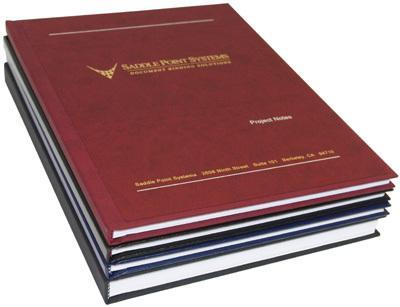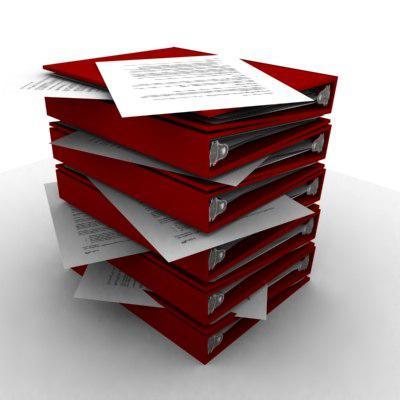The first image is the image on the left, the second image is the image on the right. Assess this claim about the two images: "An image shows a stack of at least eight binders that appears to sit on a flat surface.". Correct or not? Answer yes or no. Yes. The first image is the image on the left, the second image is the image on the right. Considering the images on both sides, is "In one image, at least one orange notebook is closed and lying flat with the opening to the back, while the second image shows at least one notebook that is orange and black with no visible contents." valid? Answer yes or no. No. 